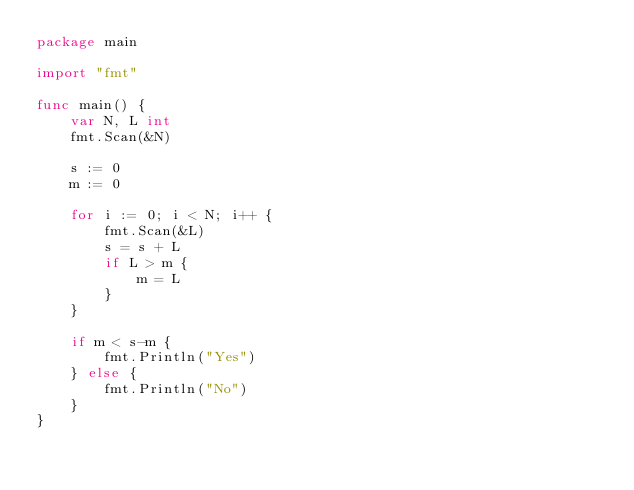<code> <loc_0><loc_0><loc_500><loc_500><_Go_>package main

import "fmt"

func main() {
	var N, L int
	fmt.Scan(&N)

	s := 0
	m := 0

	for i := 0; i < N; i++ {
		fmt.Scan(&L)
		s = s + L
		if L > m {
			m = L
		}
	}

	if m < s-m {
		fmt.Println("Yes")
	} else {
		fmt.Println("No")
	}
}</code> 